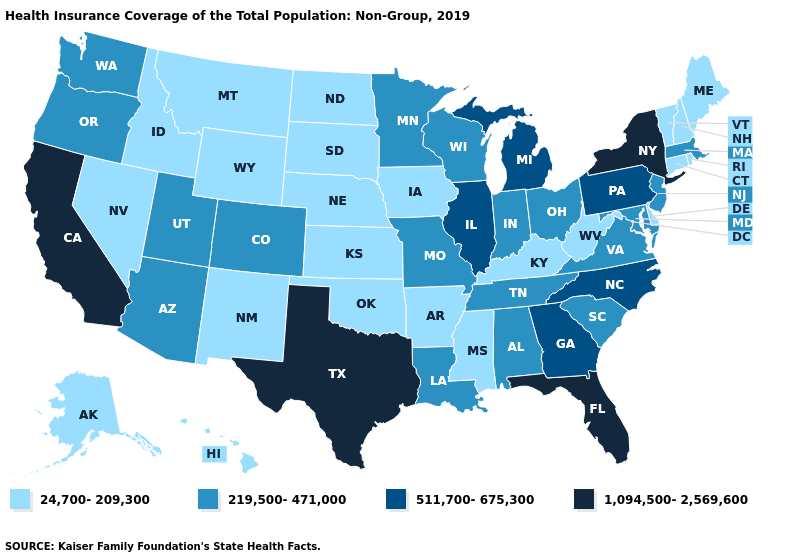Name the states that have a value in the range 219,500-471,000?
Quick response, please. Alabama, Arizona, Colorado, Indiana, Louisiana, Maryland, Massachusetts, Minnesota, Missouri, New Jersey, Ohio, Oregon, South Carolina, Tennessee, Utah, Virginia, Washington, Wisconsin. What is the value of Alaska?
Answer briefly. 24,700-209,300. What is the highest value in the Northeast ?
Be succinct. 1,094,500-2,569,600. Among the states that border Kansas , does Oklahoma have the lowest value?
Write a very short answer. Yes. Does Texas have the highest value in the USA?
Quick response, please. Yes. What is the value of Maryland?
Short answer required. 219,500-471,000. Does Vermont have the same value as Alaska?
Give a very brief answer. Yes. Does Utah have a lower value than Idaho?
Give a very brief answer. No. Does the first symbol in the legend represent the smallest category?
Give a very brief answer. Yes. What is the value of Idaho?
Concise answer only. 24,700-209,300. What is the value of Rhode Island?
Answer briefly. 24,700-209,300. Name the states that have a value in the range 511,700-675,300?
Quick response, please. Georgia, Illinois, Michigan, North Carolina, Pennsylvania. Which states have the lowest value in the USA?
Write a very short answer. Alaska, Arkansas, Connecticut, Delaware, Hawaii, Idaho, Iowa, Kansas, Kentucky, Maine, Mississippi, Montana, Nebraska, Nevada, New Hampshire, New Mexico, North Dakota, Oklahoma, Rhode Island, South Dakota, Vermont, West Virginia, Wyoming. What is the value of Maryland?
Quick response, please. 219,500-471,000. Among the states that border Delaware , which have the lowest value?
Short answer required. Maryland, New Jersey. 